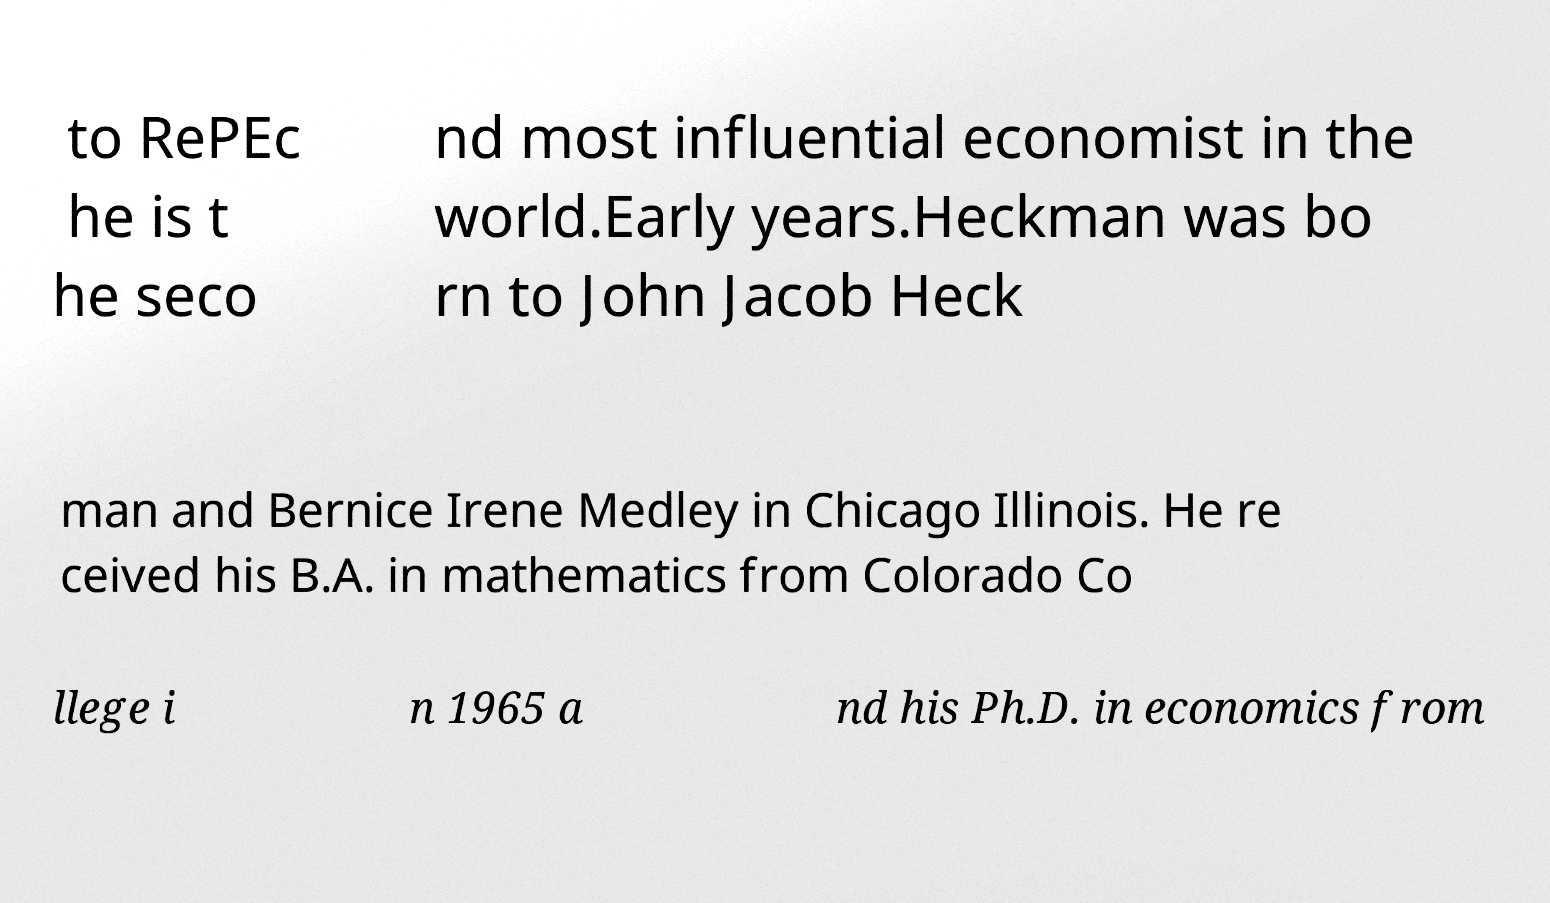Could you extract and type out the text from this image? to RePEc he is t he seco nd most influential economist in the world.Early years.Heckman was bo rn to John Jacob Heck man and Bernice Irene Medley in Chicago Illinois. He re ceived his B.A. in mathematics from Colorado Co llege i n 1965 a nd his Ph.D. in economics from 